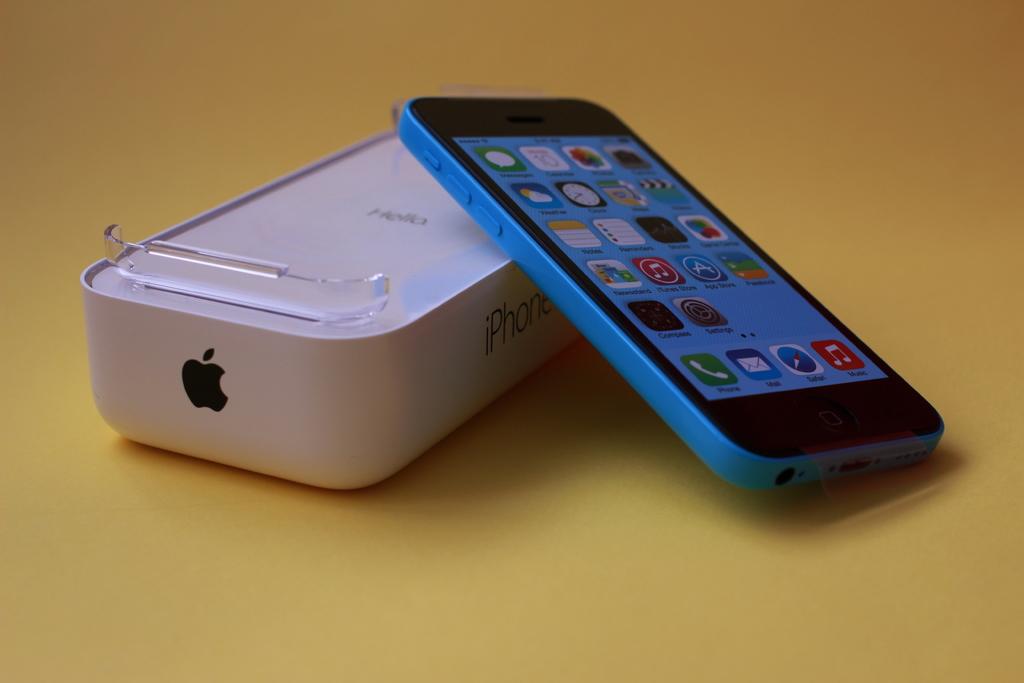What kind of phone is it?
Provide a succinct answer. Iphone. What does the red app on the bottom do?
Give a very brief answer. Music. 